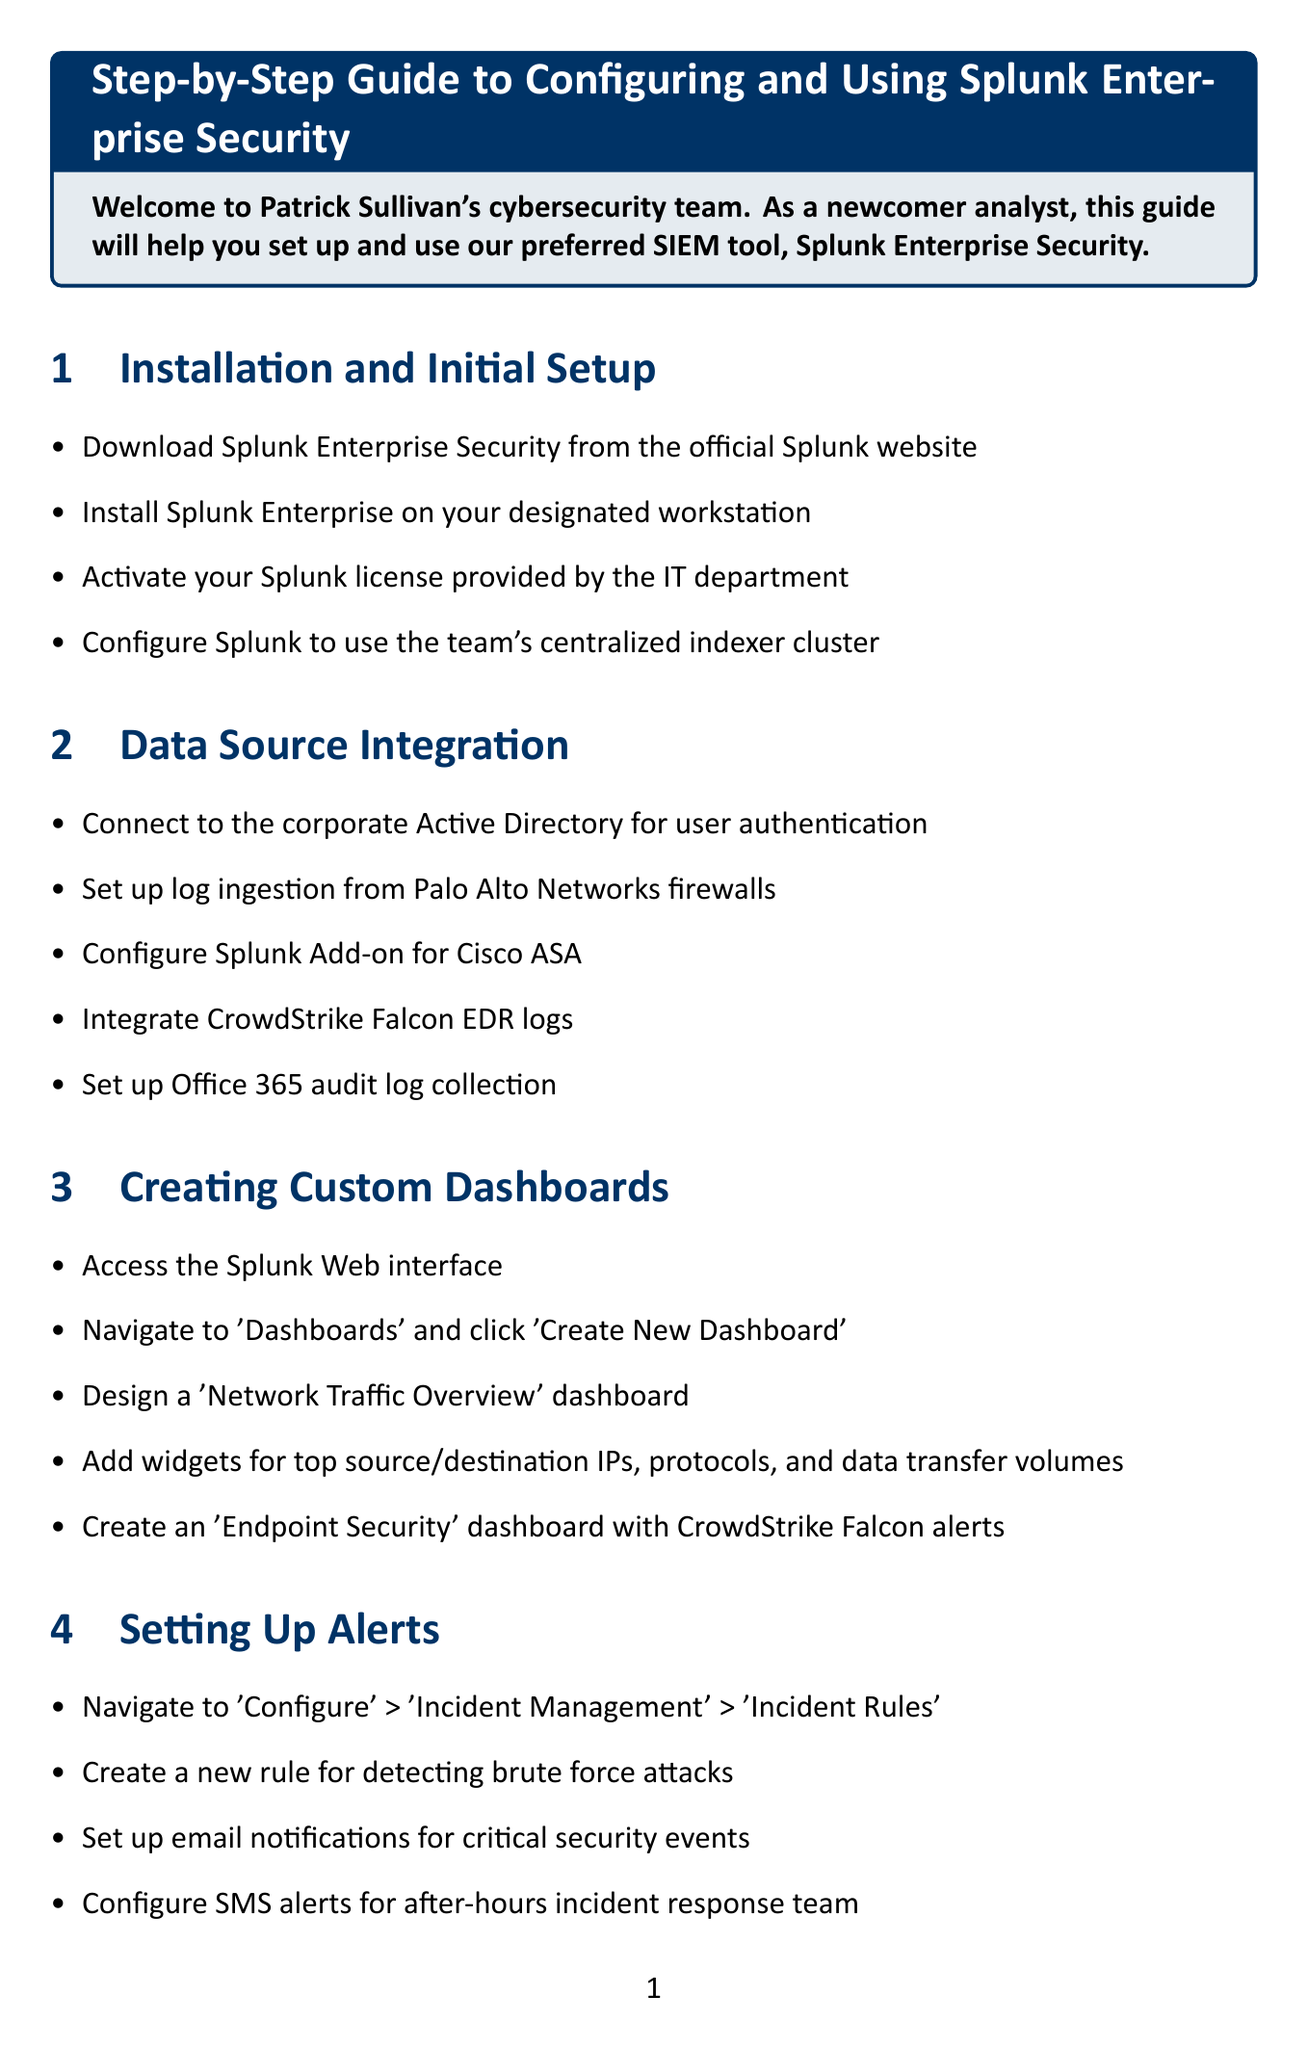What is the title of the guide? The title of the guide is provided at the beginning of the document.
Answer: Step-by-Step Guide to Configuring and Using Splunk Enterprise Security How many sections are in the guide? The number of sections is counted by identifying each distinct section from the document.
Answer: Seven What is the first step in the "Installation and Initial Setup" section? The first step is specified as the first bullet point in the relevant section.
Answer: Download Splunk Enterprise Security from the official Splunk website Which data source is integrated for user authentication? The document mentions a specific data source for authentication in the "Data Source Integration" section.
Answer: Corporate Active Directory What should you navigate to for setting up alerts? The path to navigate for setting up alerts is detailed in the "Setting Up Alerts" section.
Answer: Configure > Incident Management > Incident Rules What is one of the roles of the "Monitoring Console"? The purpose of the Monitoring Console is described under the maintenance section.
Answer: Monitor Splunk's performance What type of reports are scheduled weekly? The specific type of report to be scheduled can be found in the "Generating Reports" section.
Answer: Security posture reports for management Which tool is recommended for running ad-hoc queries? The recommended tool for this purpose is identified in the "Running Searches and Investigations" section.
Answer: Search & Reporting app Where can you find Splunk's documentation? The location of Splunk's documentation is provided in the "Additional Resources" section.
Answer: https://docs.splunk.com/Documentation/Splunk 